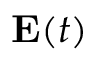Convert formula to latex. <formula><loc_0><loc_0><loc_500><loc_500>E ( t )</formula> 